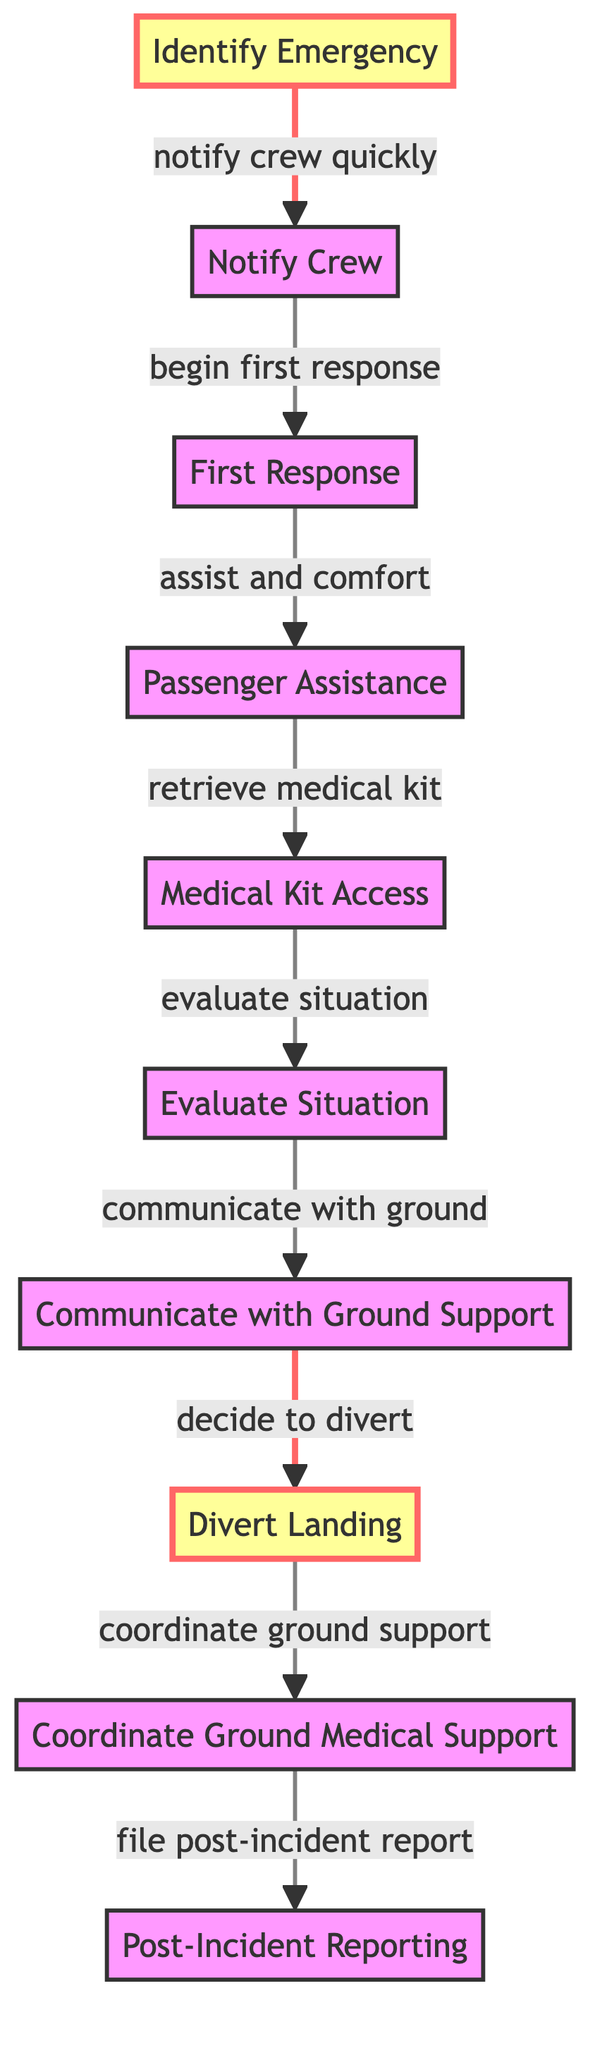What is the first step in the emergency protocol? The diagram indicates that the first step in the emergency protocol is labeled as "Identify Emergency."
Answer: Identify Emergency How many steps are there in total in the emergency protocol? By counting the nodes in the diagram, there are a total of 10 steps in the emergency protocol.
Answer: 10 Which step follows "Notify Crew"? According to the diagram, the step that follows "Notify Crew" is "First Response."
Answer: First Response What action is taken after evaluating the situation? The diagram shows that after "Evaluate Situation," the next action is to "Communicate with Ground Support."
Answer: Communicate with Ground Support What is the importance of the node "Divert Landing"? The node "Divert Landing" is highlighted with the important class, indicating it is crucial in the emergency protocol.
Answer: Crucial What needs to be retrieved after assisting passengers? The diagram indicates that after "Assist and Comfort," the next step is to "Retrieve Medical Kit."
Answer: Retrieve Medical Kit How does the flow move from "Communicate with Ground Support"? The flow shows that after "Communicate with Ground Support," the action is to "Decide to Divert."
Answer: Decide to Divert Which nodes are indicated as important in the protocol? The nodes "Identify Emergency" and "Divert Landing" are indicated as important in the protocol due to their specific highlight.
Answer: Identify Emergency, Divert Landing What does the final step entail? The final step in the protocol is "Post-Incident Reporting," which involves documenting the incident afterward.
Answer: Post-Incident Reporting 